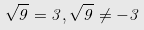Convert formula to latex. <formula><loc_0><loc_0><loc_500><loc_500>\sqrt { 9 } = 3 , \sqrt { 9 } \ne - 3</formula> 